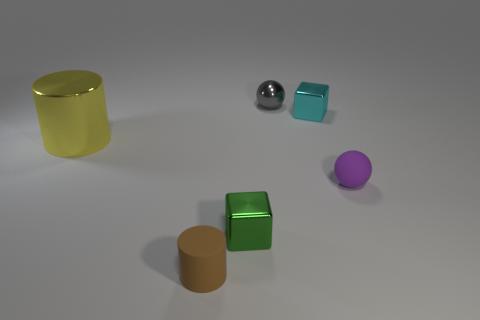There is a brown rubber object; are there any things left of it?
Your response must be concise. Yes. There is a small matte thing that is right of the gray sphere; what number of objects are to the left of it?
Make the answer very short. 5. What size is the yellow cylinder that is the same material as the tiny green thing?
Your answer should be compact. Large. What size is the matte cylinder?
Give a very brief answer. Small. Is the material of the yellow cylinder the same as the tiny cyan cube?
Make the answer very short. Yes. How many cylinders are green objects or gray metallic objects?
Ensure brevity in your answer.  0. What is the color of the small sphere in front of the small cube that is behind the rubber ball?
Your answer should be compact. Purple. There is a purple rubber thing in front of the small ball that is to the left of the purple rubber ball; how many brown matte things are to the right of it?
Your response must be concise. 0. There is a tiny matte object behind the small brown cylinder; is it the same shape as the metallic object that is behind the small cyan metallic cube?
Provide a succinct answer. Yes. How many things are either tiny rubber things or big gray matte blocks?
Offer a very short reply. 2. 